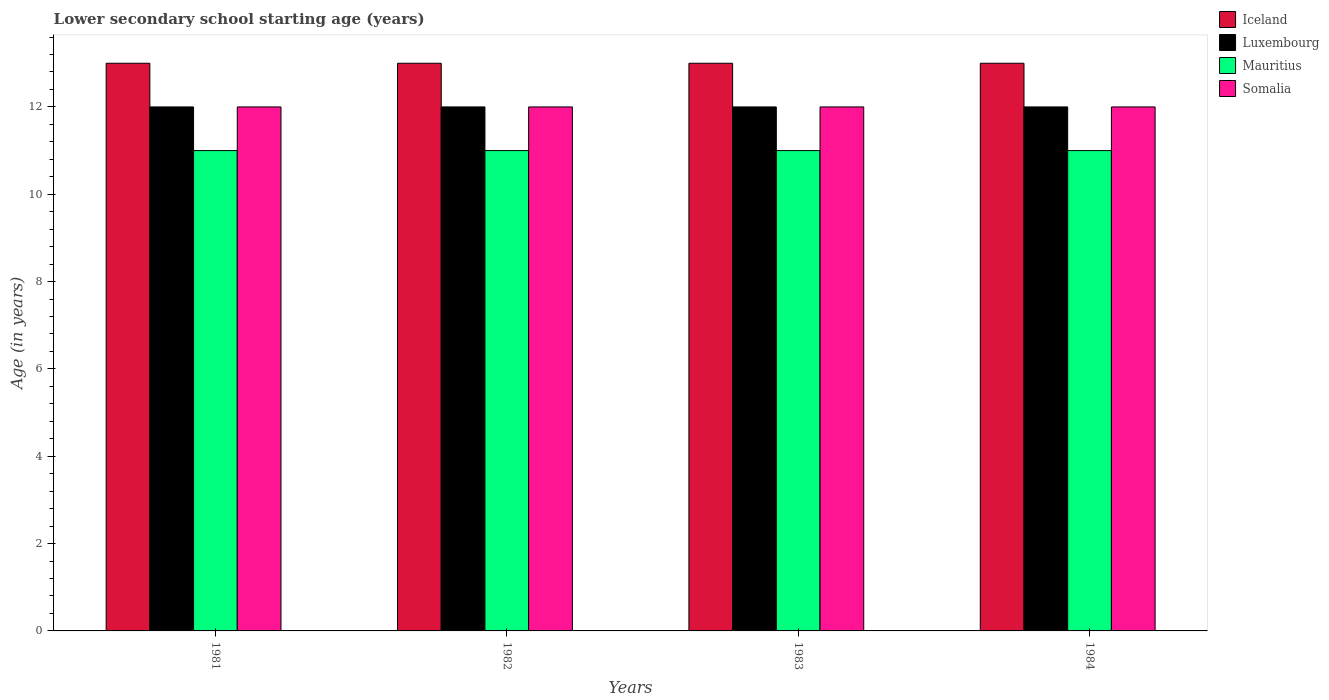How many different coloured bars are there?
Offer a very short reply. 4. In how many cases, is the number of bars for a given year not equal to the number of legend labels?
Offer a terse response. 0. What is the lower secondary school starting age of children in Somalia in 1984?
Make the answer very short. 12. Across all years, what is the maximum lower secondary school starting age of children in Luxembourg?
Provide a short and direct response. 12. Across all years, what is the minimum lower secondary school starting age of children in Iceland?
Provide a short and direct response. 13. In which year was the lower secondary school starting age of children in Iceland maximum?
Provide a succinct answer. 1981. In which year was the lower secondary school starting age of children in Mauritius minimum?
Provide a succinct answer. 1981. What is the total lower secondary school starting age of children in Somalia in the graph?
Give a very brief answer. 48. What is the average lower secondary school starting age of children in Iceland per year?
Make the answer very short. 13. In the year 1981, what is the difference between the lower secondary school starting age of children in Somalia and lower secondary school starting age of children in Iceland?
Keep it short and to the point. -1. What is the ratio of the lower secondary school starting age of children in Luxembourg in 1982 to that in 1984?
Make the answer very short. 1. Is the difference between the lower secondary school starting age of children in Somalia in 1981 and 1983 greater than the difference between the lower secondary school starting age of children in Iceland in 1981 and 1983?
Your response must be concise. No. What is the difference between the highest and the lowest lower secondary school starting age of children in Somalia?
Your response must be concise. 0. Is the sum of the lower secondary school starting age of children in Somalia in 1981 and 1983 greater than the maximum lower secondary school starting age of children in Luxembourg across all years?
Ensure brevity in your answer.  Yes. Is it the case that in every year, the sum of the lower secondary school starting age of children in Luxembourg and lower secondary school starting age of children in Iceland is greater than the sum of lower secondary school starting age of children in Mauritius and lower secondary school starting age of children in Somalia?
Provide a succinct answer. No. What does the 3rd bar from the left in 1981 represents?
Make the answer very short. Mauritius. How many years are there in the graph?
Your response must be concise. 4. What is the difference between two consecutive major ticks on the Y-axis?
Your answer should be very brief. 2. Are the values on the major ticks of Y-axis written in scientific E-notation?
Make the answer very short. No. Does the graph contain any zero values?
Offer a terse response. No. Where does the legend appear in the graph?
Keep it short and to the point. Top right. How many legend labels are there?
Your answer should be very brief. 4. What is the title of the graph?
Keep it short and to the point. Lower secondary school starting age (years). What is the label or title of the Y-axis?
Offer a terse response. Age (in years). What is the Age (in years) in Iceland in 1981?
Provide a short and direct response. 13. What is the Age (in years) in Luxembourg in 1981?
Your answer should be very brief. 12. What is the Age (in years) in Mauritius in 1984?
Make the answer very short. 11. What is the Age (in years) of Somalia in 1984?
Provide a short and direct response. 12. Across all years, what is the minimum Age (in years) of Iceland?
Provide a succinct answer. 13. Across all years, what is the minimum Age (in years) in Luxembourg?
Provide a short and direct response. 12. Across all years, what is the minimum Age (in years) in Mauritius?
Your response must be concise. 11. Across all years, what is the minimum Age (in years) in Somalia?
Provide a succinct answer. 12. What is the difference between the Age (in years) of Iceland in 1981 and that in 1982?
Your response must be concise. 0. What is the difference between the Age (in years) of Luxembourg in 1981 and that in 1982?
Offer a terse response. 0. What is the difference between the Age (in years) of Mauritius in 1981 and that in 1982?
Ensure brevity in your answer.  0. What is the difference between the Age (in years) of Luxembourg in 1981 and that in 1983?
Provide a short and direct response. 0. What is the difference between the Age (in years) in Mauritius in 1981 and that in 1983?
Your answer should be compact. 0. What is the difference between the Age (in years) of Iceland in 1981 and that in 1984?
Your answer should be very brief. 0. What is the difference between the Age (in years) in Somalia in 1981 and that in 1984?
Your answer should be very brief. 0. What is the difference between the Age (in years) of Luxembourg in 1982 and that in 1983?
Offer a very short reply. 0. What is the difference between the Age (in years) of Iceland in 1982 and that in 1984?
Your answer should be very brief. 0. What is the difference between the Age (in years) in Luxembourg in 1982 and that in 1984?
Provide a short and direct response. 0. What is the difference between the Age (in years) of Somalia in 1982 and that in 1984?
Ensure brevity in your answer.  0. What is the difference between the Age (in years) in Mauritius in 1983 and that in 1984?
Give a very brief answer. 0. What is the difference between the Age (in years) of Somalia in 1983 and that in 1984?
Offer a terse response. 0. What is the difference between the Age (in years) in Luxembourg in 1981 and the Age (in years) in Mauritius in 1982?
Your answer should be very brief. 1. What is the difference between the Age (in years) of Mauritius in 1981 and the Age (in years) of Somalia in 1983?
Your answer should be compact. -1. What is the difference between the Age (in years) in Luxembourg in 1981 and the Age (in years) in Mauritius in 1984?
Offer a very short reply. 1. What is the difference between the Age (in years) of Mauritius in 1981 and the Age (in years) of Somalia in 1984?
Provide a succinct answer. -1. What is the difference between the Age (in years) in Iceland in 1982 and the Age (in years) in Luxembourg in 1983?
Offer a terse response. 1. What is the difference between the Age (in years) in Luxembourg in 1982 and the Age (in years) in Somalia in 1983?
Your answer should be very brief. 0. What is the difference between the Age (in years) in Mauritius in 1982 and the Age (in years) in Somalia in 1983?
Keep it short and to the point. -1. What is the difference between the Age (in years) in Luxembourg in 1982 and the Age (in years) in Somalia in 1984?
Offer a very short reply. 0. What is the difference between the Age (in years) in Mauritius in 1982 and the Age (in years) in Somalia in 1984?
Ensure brevity in your answer.  -1. What is the difference between the Age (in years) of Iceland in 1983 and the Age (in years) of Somalia in 1984?
Provide a short and direct response. 1. What is the average Age (in years) in Iceland per year?
Offer a terse response. 13. What is the average Age (in years) of Mauritius per year?
Give a very brief answer. 11. In the year 1981, what is the difference between the Age (in years) of Iceland and Age (in years) of Somalia?
Offer a terse response. 1. In the year 1982, what is the difference between the Age (in years) of Iceland and Age (in years) of Luxembourg?
Provide a succinct answer. 1. In the year 1982, what is the difference between the Age (in years) of Luxembourg and Age (in years) of Somalia?
Provide a succinct answer. 0. In the year 1983, what is the difference between the Age (in years) in Iceland and Age (in years) in Mauritius?
Your answer should be very brief. 2. In the year 1983, what is the difference between the Age (in years) in Luxembourg and Age (in years) in Somalia?
Keep it short and to the point. 0. In the year 1983, what is the difference between the Age (in years) of Mauritius and Age (in years) of Somalia?
Give a very brief answer. -1. In the year 1984, what is the difference between the Age (in years) in Iceland and Age (in years) in Luxembourg?
Make the answer very short. 1. In the year 1984, what is the difference between the Age (in years) in Iceland and Age (in years) in Mauritius?
Offer a very short reply. 2. In the year 1984, what is the difference between the Age (in years) in Iceland and Age (in years) in Somalia?
Give a very brief answer. 1. In the year 1984, what is the difference between the Age (in years) in Luxembourg and Age (in years) in Mauritius?
Give a very brief answer. 1. What is the ratio of the Age (in years) of Iceland in 1981 to that in 1982?
Make the answer very short. 1. What is the ratio of the Age (in years) of Iceland in 1981 to that in 1983?
Give a very brief answer. 1. What is the ratio of the Age (in years) of Somalia in 1981 to that in 1983?
Your answer should be very brief. 1. What is the ratio of the Age (in years) in Iceland in 1981 to that in 1984?
Give a very brief answer. 1. What is the ratio of the Age (in years) in Luxembourg in 1981 to that in 1984?
Keep it short and to the point. 1. What is the ratio of the Age (in years) of Somalia in 1981 to that in 1984?
Offer a very short reply. 1. What is the ratio of the Age (in years) in Iceland in 1982 to that in 1983?
Offer a terse response. 1. What is the ratio of the Age (in years) in Luxembourg in 1982 to that in 1983?
Your answer should be very brief. 1. What is the ratio of the Age (in years) in Somalia in 1982 to that in 1983?
Offer a terse response. 1. What is the ratio of the Age (in years) of Mauritius in 1982 to that in 1984?
Keep it short and to the point. 1. What is the ratio of the Age (in years) of Luxembourg in 1983 to that in 1984?
Offer a very short reply. 1. What is the ratio of the Age (in years) in Mauritius in 1983 to that in 1984?
Ensure brevity in your answer.  1. What is the ratio of the Age (in years) in Somalia in 1983 to that in 1984?
Provide a succinct answer. 1. What is the difference between the highest and the second highest Age (in years) in Iceland?
Your response must be concise. 0. What is the difference between the highest and the second highest Age (in years) in Luxembourg?
Keep it short and to the point. 0. What is the difference between the highest and the second highest Age (in years) in Mauritius?
Keep it short and to the point. 0. What is the difference between the highest and the lowest Age (in years) in Iceland?
Ensure brevity in your answer.  0. What is the difference between the highest and the lowest Age (in years) of Mauritius?
Your response must be concise. 0. 